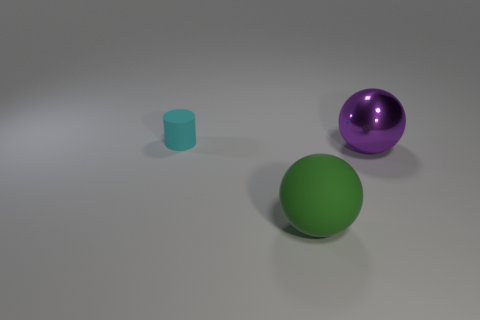How many things are objects to the left of the metal ball or rubber objects that are on the left side of the large green rubber ball?
Provide a succinct answer. 2. What number of other things are the same color as the rubber cylinder?
Offer a very short reply. 0. Is the number of small cyan things in front of the metallic ball less than the number of cylinders that are to the left of the big green sphere?
Give a very brief answer. Yes. How many tiny matte objects are there?
Your answer should be very brief. 1. Is there anything else that is the same material as the large purple thing?
Provide a short and direct response. No. There is another object that is the same shape as the big green rubber object; what is its material?
Make the answer very short. Metal. Are there fewer green matte balls that are behind the green sphere than cyan cylinders?
Give a very brief answer. Yes. There is a rubber thing that is behind the large purple metal thing; does it have the same shape as the purple object?
Your answer should be compact. No. Is there any other thing that is the same color as the tiny cylinder?
Your response must be concise. No. There is another object that is the same material as the small thing; what size is it?
Your response must be concise. Large. 